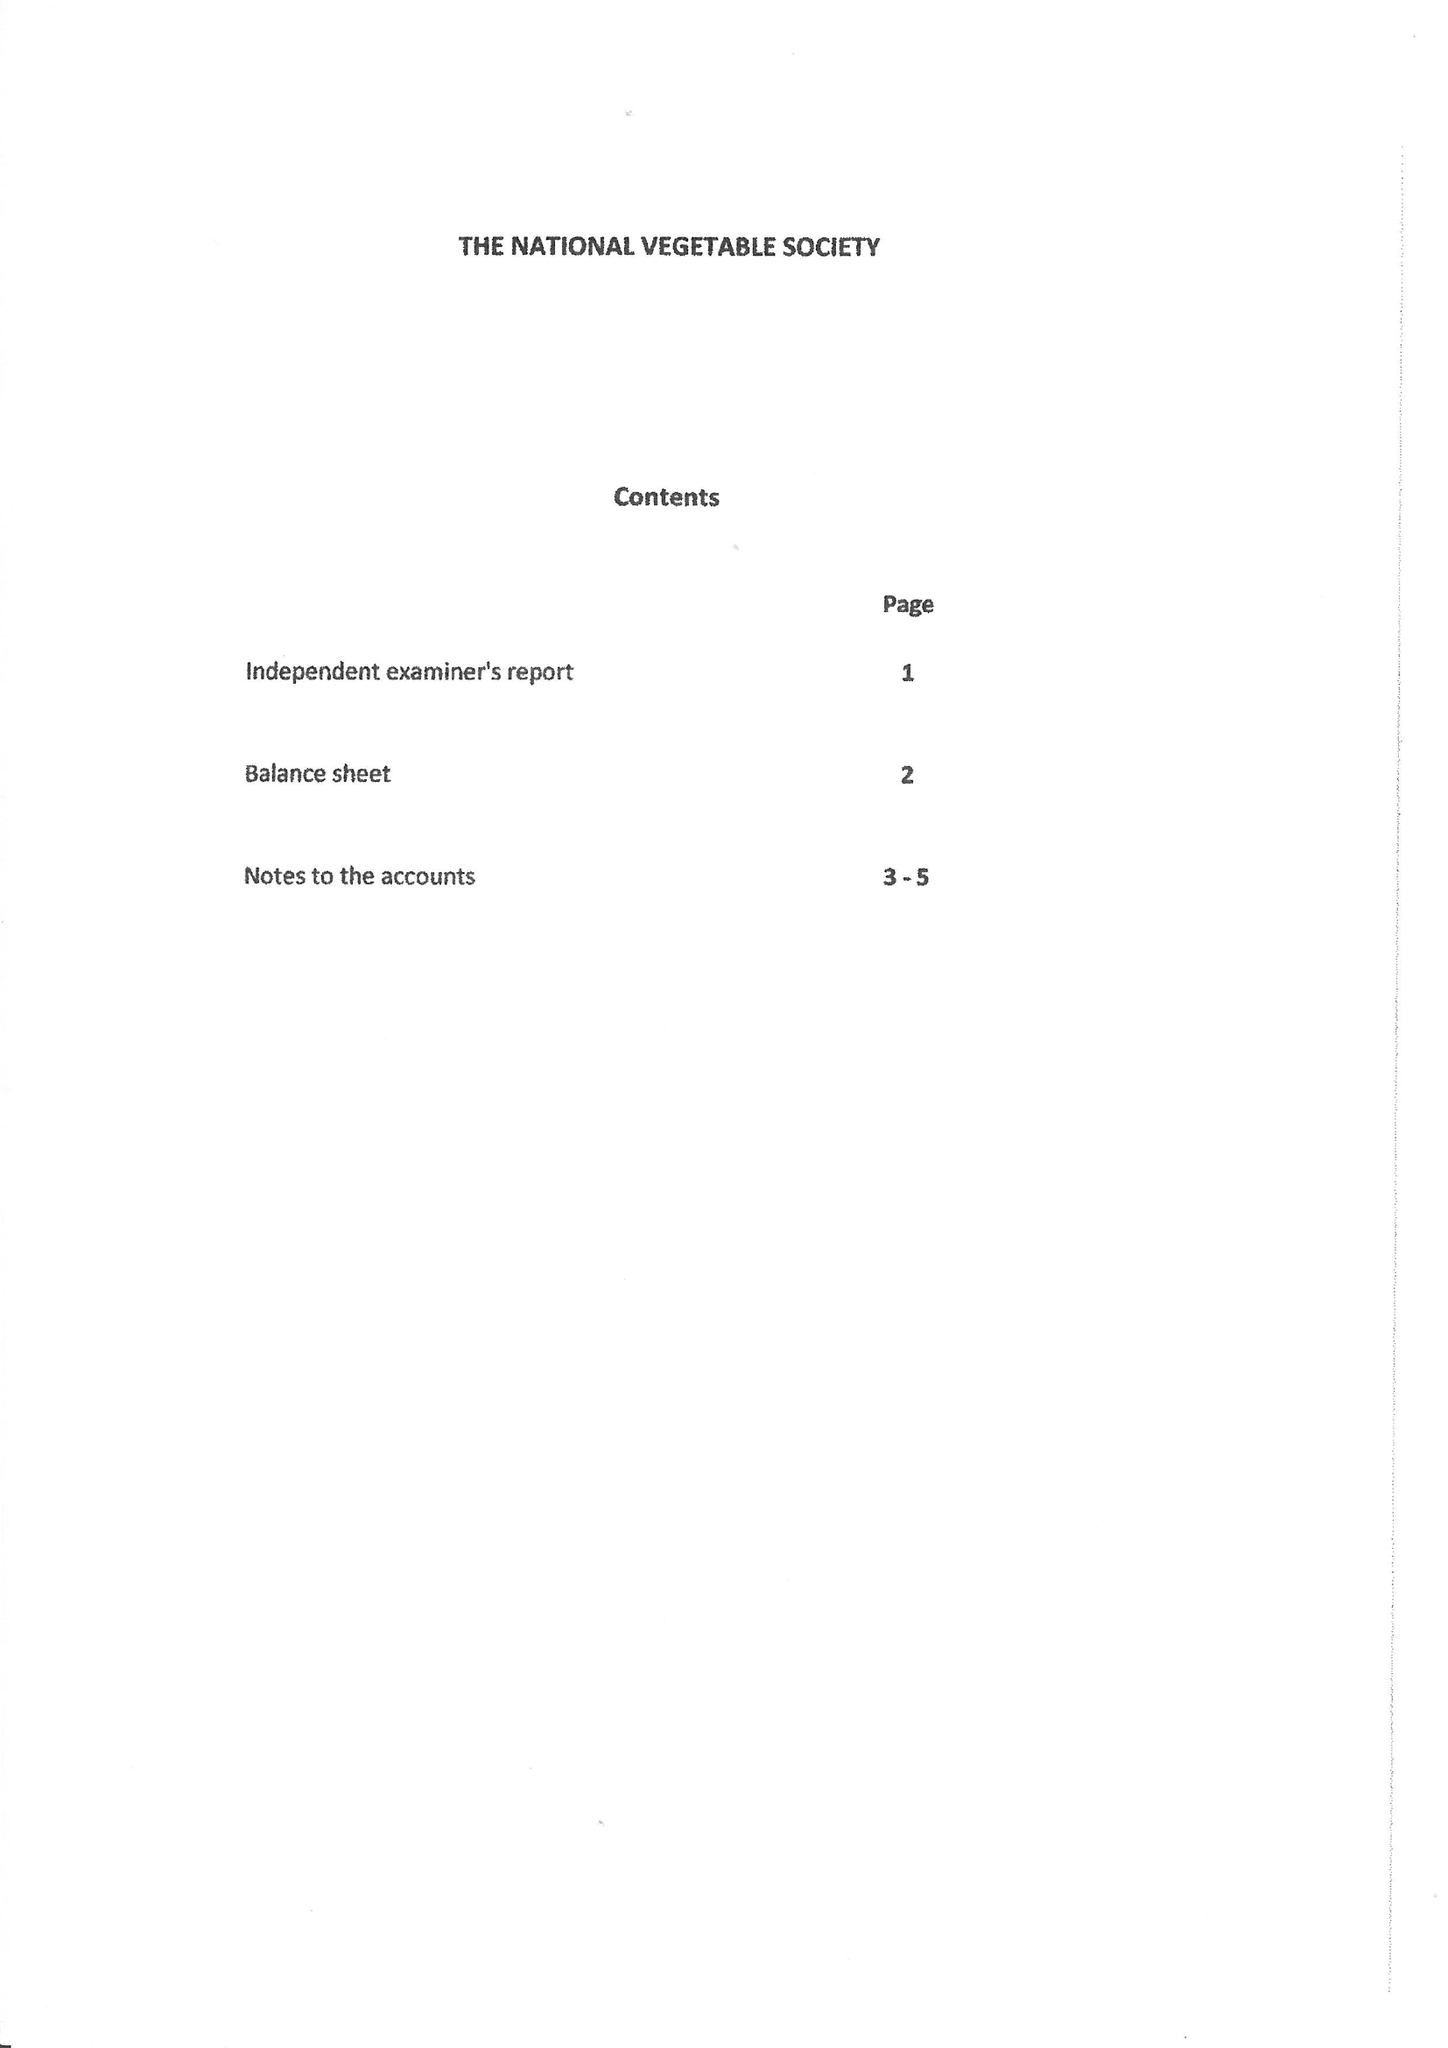What is the value for the address__post_town?
Answer the question using a single word or phrase. BURNTISLAND 